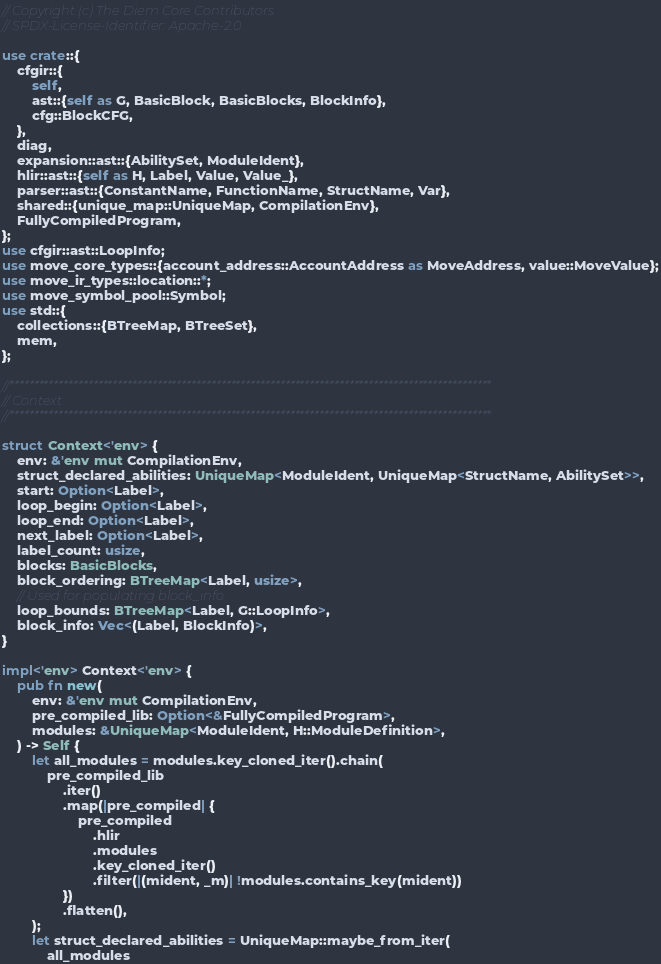<code> <loc_0><loc_0><loc_500><loc_500><_Rust_>// Copyright (c) The Diem Core Contributors
// SPDX-License-Identifier: Apache-2.0

use crate::{
    cfgir::{
        self,
        ast::{self as G, BasicBlock, BasicBlocks, BlockInfo},
        cfg::BlockCFG,
    },
    diag,
    expansion::ast::{AbilitySet, ModuleIdent},
    hlir::ast::{self as H, Label, Value, Value_},
    parser::ast::{ConstantName, FunctionName, StructName, Var},
    shared::{unique_map::UniqueMap, CompilationEnv},
    FullyCompiledProgram,
};
use cfgir::ast::LoopInfo;
use move_core_types::{account_address::AccountAddress as MoveAddress, value::MoveValue};
use move_ir_types::location::*;
use move_symbol_pool::Symbol;
use std::{
    collections::{BTreeMap, BTreeSet},
    mem,
};

//**************************************************************************************************
// Context
//**************************************************************************************************

struct Context<'env> {
    env: &'env mut CompilationEnv,
    struct_declared_abilities: UniqueMap<ModuleIdent, UniqueMap<StructName, AbilitySet>>,
    start: Option<Label>,
    loop_begin: Option<Label>,
    loop_end: Option<Label>,
    next_label: Option<Label>,
    label_count: usize,
    blocks: BasicBlocks,
    block_ordering: BTreeMap<Label, usize>,
    // Used for populating block_info
    loop_bounds: BTreeMap<Label, G::LoopInfo>,
    block_info: Vec<(Label, BlockInfo)>,
}

impl<'env> Context<'env> {
    pub fn new(
        env: &'env mut CompilationEnv,
        pre_compiled_lib: Option<&FullyCompiledProgram>,
        modules: &UniqueMap<ModuleIdent, H::ModuleDefinition>,
    ) -> Self {
        let all_modules = modules.key_cloned_iter().chain(
            pre_compiled_lib
                .iter()
                .map(|pre_compiled| {
                    pre_compiled
                        .hlir
                        .modules
                        .key_cloned_iter()
                        .filter(|(mident, _m)| !modules.contains_key(mident))
                })
                .flatten(),
        );
        let struct_declared_abilities = UniqueMap::maybe_from_iter(
            all_modules</code> 